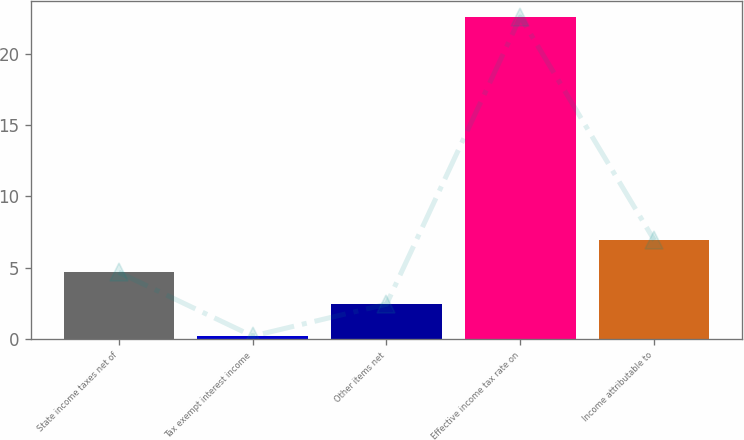Convert chart. <chart><loc_0><loc_0><loc_500><loc_500><bar_chart><fcel>State income taxes net of<fcel>Tax exempt interest income<fcel>Other items net<fcel>Effective income tax rate on<fcel>Income attributable to<nl><fcel>4.68<fcel>0.2<fcel>2.44<fcel>22.6<fcel>6.92<nl></chart> 